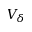Convert formula to latex. <formula><loc_0><loc_0><loc_500><loc_500>V _ { \delta }</formula> 